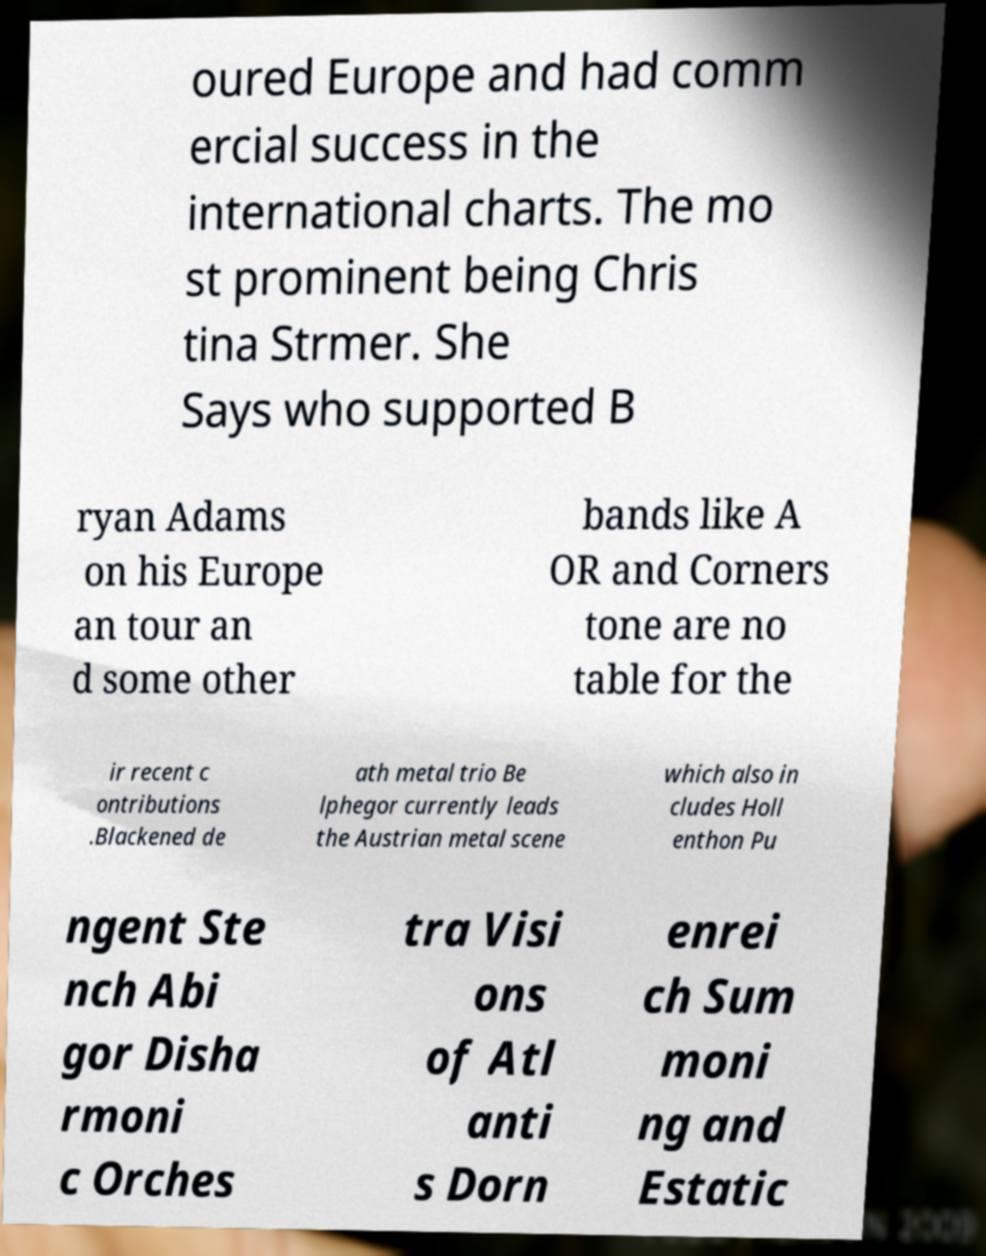I need the written content from this picture converted into text. Can you do that? oured Europe and had comm ercial success in the international charts. The mo st prominent being Chris tina Strmer. She Says who supported B ryan Adams on his Europe an tour an d some other bands like A OR and Corners tone are no table for the ir recent c ontributions .Blackened de ath metal trio Be lphegor currently leads the Austrian metal scene which also in cludes Holl enthon Pu ngent Ste nch Abi gor Disha rmoni c Orches tra Visi ons of Atl anti s Dorn enrei ch Sum moni ng and Estatic 